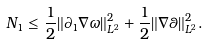<formula> <loc_0><loc_0><loc_500><loc_500>N _ { 1 } \leq \frac { 1 } { 2 } \| \partial _ { 1 } \nabla \omega \| _ { L ^ { 2 } } ^ { 2 } + \frac { 1 } { 2 } \| \nabla \theta \| _ { L ^ { 2 } } ^ { 2 } .</formula> 